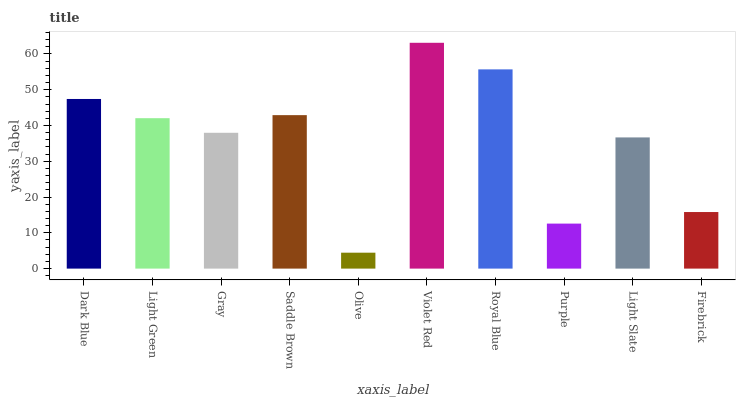Is Light Green the minimum?
Answer yes or no. No. Is Light Green the maximum?
Answer yes or no. No. Is Dark Blue greater than Light Green?
Answer yes or no. Yes. Is Light Green less than Dark Blue?
Answer yes or no. Yes. Is Light Green greater than Dark Blue?
Answer yes or no. No. Is Dark Blue less than Light Green?
Answer yes or no. No. Is Light Green the high median?
Answer yes or no. Yes. Is Gray the low median?
Answer yes or no. Yes. Is Dark Blue the high median?
Answer yes or no. No. Is Light Green the low median?
Answer yes or no. No. 